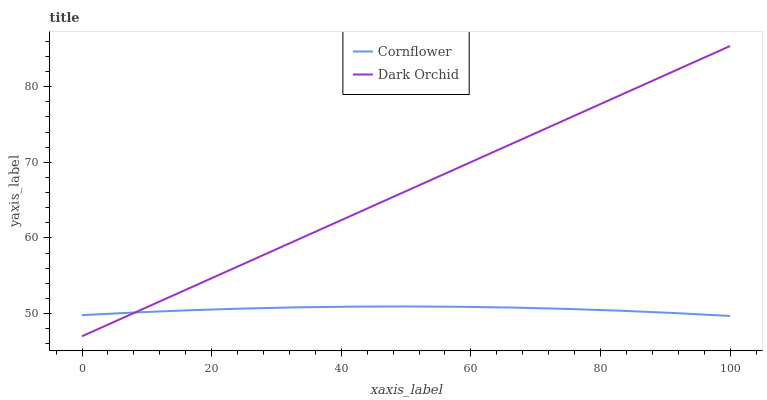Does Cornflower have the minimum area under the curve?
Answer yes or no. Yes. Does Dark Orchid have the maximum area under the curve?
Answer yes or no. Yes. Does Dark Orchid have the minimum area under the curve?
Answer yes or no. No. Is Dark Orchid the smoothest?
Answer yes or no. Yes. Is Cornflower the roughest?
Answer yes or no. Yes. Is Dark Orchid the roughest?
Answer yes or no. No. Does Dark Orchid have the lowest value?
Answer yes or no. Yes. Does Dark Orchid have the highest value?
Answer yes or no. Yes. Does Dark Orchid intersect Cornflower?
Answer yes or no. Yes. Is Dark Orchid less than Cornflower?
Answer yes or no. No. Is Dark Orchid greater than Cornflower?
Answer yes or no. No. 